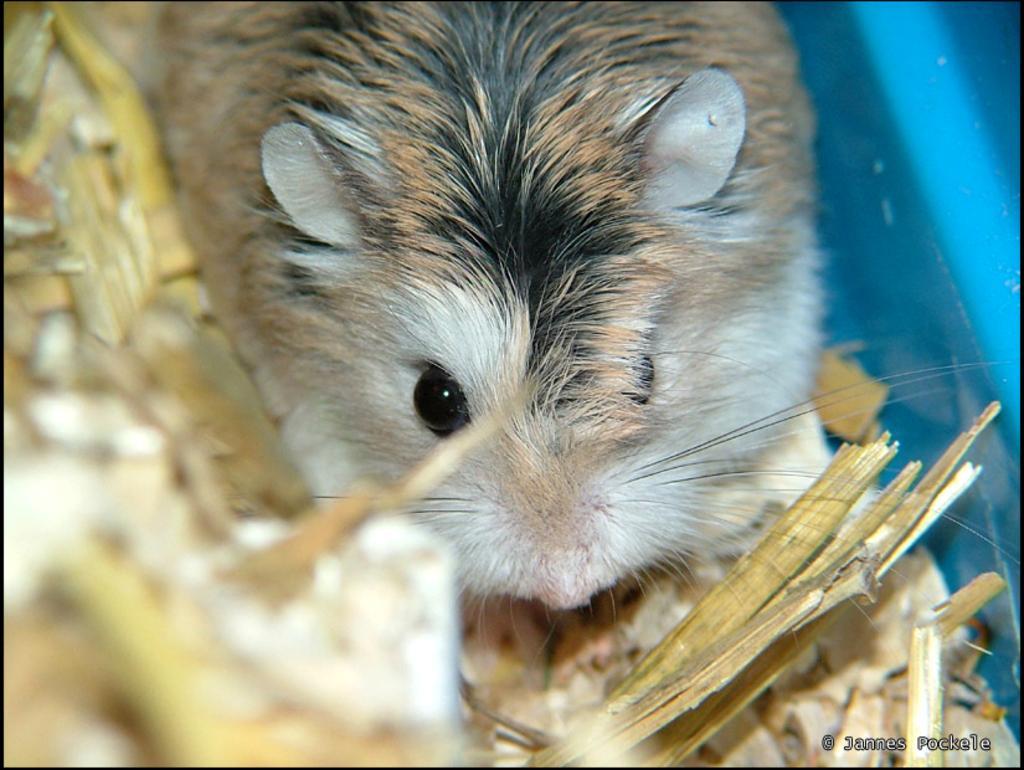Can you describe this image briefly? In this image we can see an animal and some wooden pieces around it. 